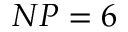<formula> <loc_0><loc_0><loc_500><loc_500>N P = 6</formula> 